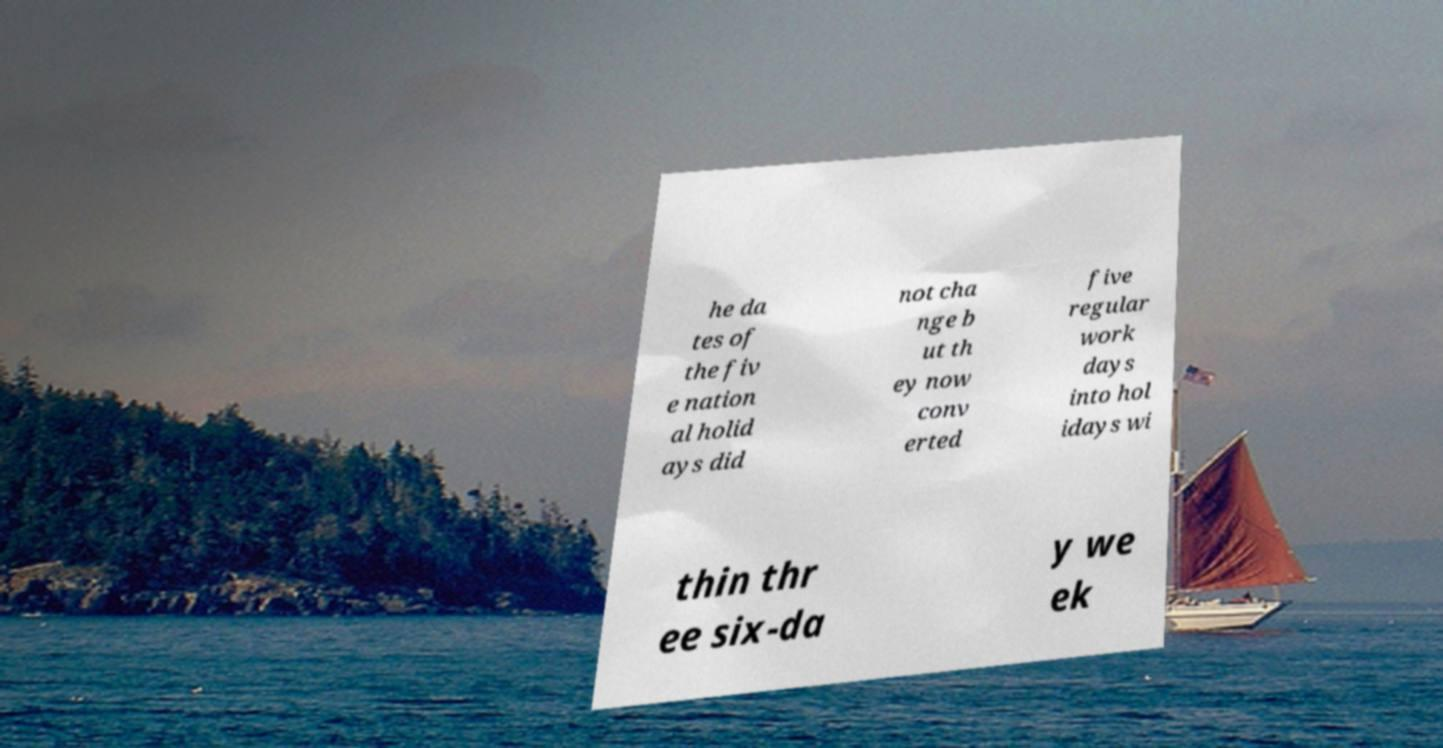I need the written content from this picture converted into text. Can you do that? he da tes of the fiv e nation al holid ays did not cha nge b ut th ey now conv erted five regular work days into hol idays wi thin thr ee six-da y we ek 